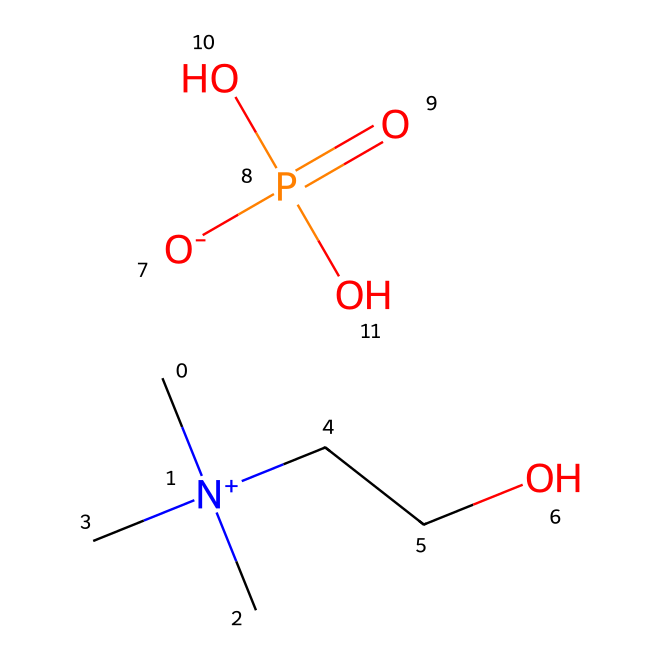What is the molecular formula of choline dihydrogen phosphate? The SMILES representation contains the elements carbon (C), nitrogen (N), oxygen (O), and phosphorus (P). Counting the atoms gives us C5, H15, N1, O4, P1. So, the molecular formula is C5H15NO4P.
Answer: C5H15NO4P How many oxygen atoms are present in the chemical structure? By examining the SMILES notation, we can see that there are four instances of the letter 'O', indicating there are four oxygen atoms in total.
Answer: 4 Which functional group is present in this ionic liquid that contributes to its ionic nature? The presence of the quaternary ammonium group (noted by the 'N+' attached to three carbon atoms) provides the ionic character due to the positive charge, leading to its classification as an ionic liquid.
Answer: quaternary ammonium group What type of compounds are formed from the phosphate group in this structure? The phosphate group typically forms anions; in this case, it is part of the dihydrogen phosphate ion (H2PO4-), which carries a negative charge making part of the ionic structure of the liquid.
Answer: dihydrogen phosphate How many total bonds can be inferred from the primary structure presented in the SMILES? The SMILES notation allows us to visualize the connectivity: there are 12 individual bonds, including both carbon-hydrogen and other interatomic bonds. This can be counted directly by analyzing the structure implied by the SMILES.
Answer: 12 Is choline dihydrogen phosphate considered hydrophilic or hydrophobic? Given the presence of polar functional groups, especially the hydroxyl (-OH) and phosphate groups, this ionic liquid will interact favorably with water, classifying it as hydrophilic.
Answer: hydrophilic 